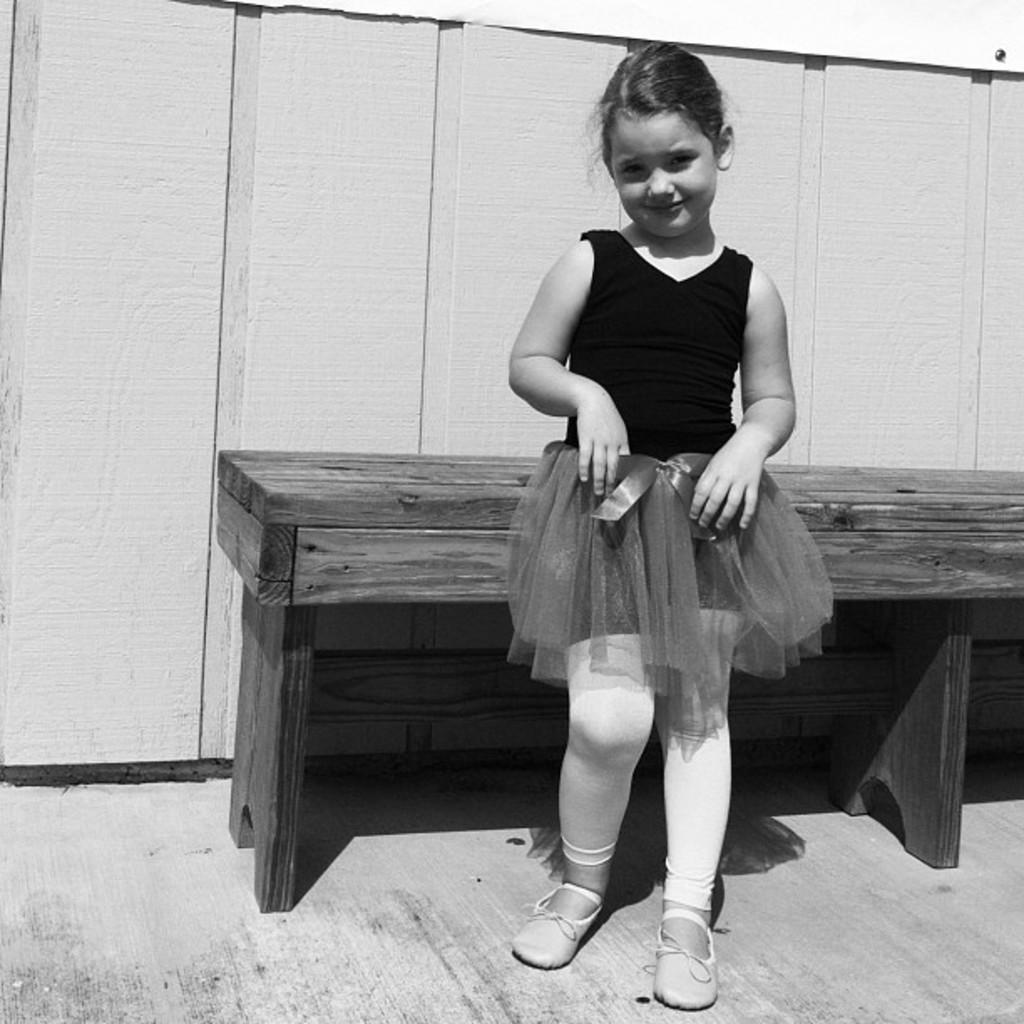Describe this image in one or two sentences. In this image there is a girl standing beside a wooden bench and a wooden fence. 